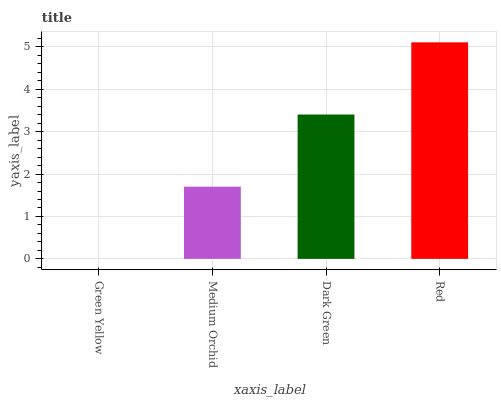Is Green Yellow the minimum?
Answer yes or no. Yes. Is Red the maximum?
Answer yes or no. Yes. Is Medium Orchid the minimum?
Answer yes or no. No. Is Medium Orchid the maximum?
Answer yes or no. No. Is Medium Orchid greater than Green Yellow?
Answer yes or no. Yes. Is Green Yellow less than Medium Orchid?
Answer yes or no. Yes. Is Green Yellow greater than Medium Orchid?
Answer yes or no. No. Is Medium Orchid less than Green Yellow?
Answer yes or no. No. Is Dark Green the high median?
Answer yes or no. Yes. Is Medium Orchid the low median?
Answer yes or no. Yes. Is Green Yellow the high median?
Answer yes or no. No. Is Green Yellow the low median?
Answer yes or no. No. 